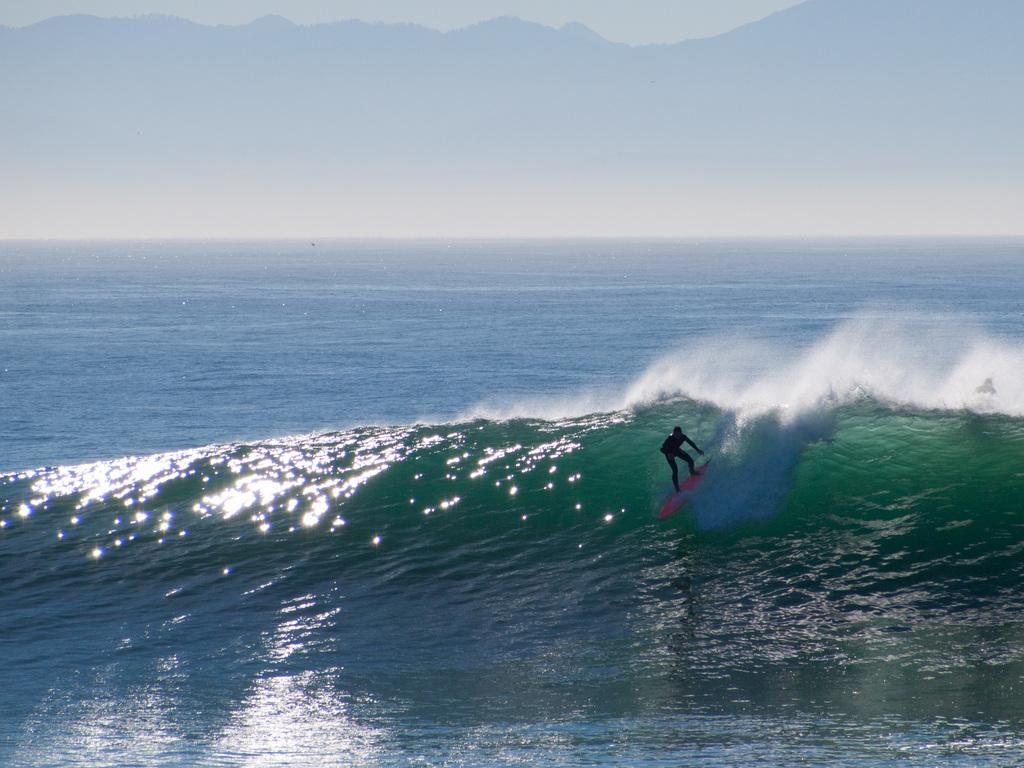Who is the main subject in the image? There is a person in the image. What activity is the person engaged in? The person is surfing. Where is the surfing taking place? The surfing is taking place in the ocean. What can be seen in the sky in the image? The sky is visible in the image, and clouds are present. What type of print can be seen on the surfboard in the image? There is no print visible on the surfboard in the image. Can you see any chickens in the image? No, there are no chickens present in the image. 